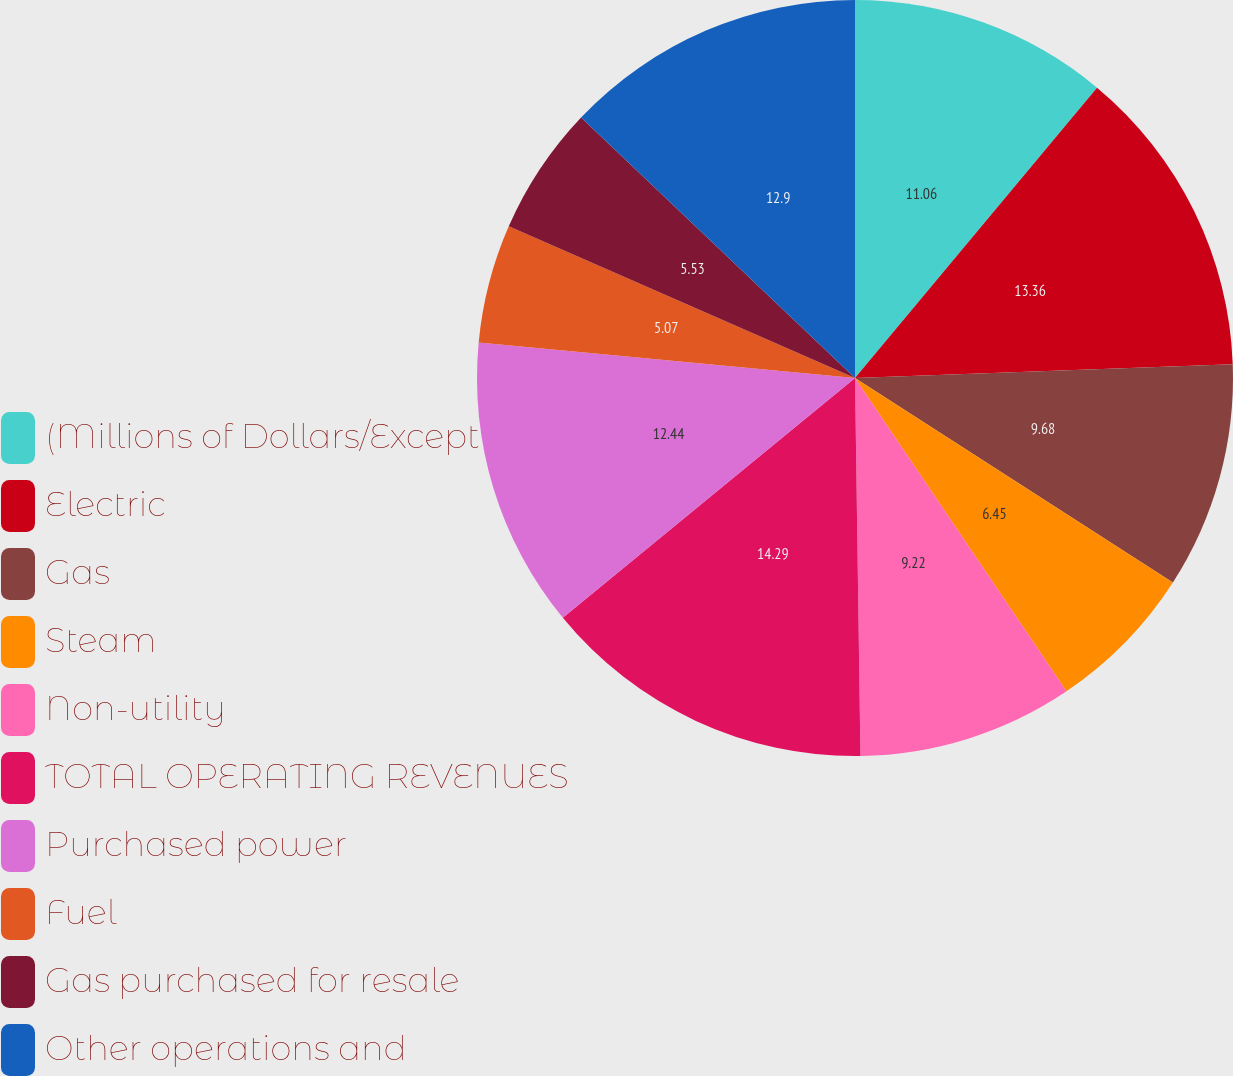Convert chart. <chart><loc_0><loc_0><loc_500><loc_500><pie_chart><fcel>(Millions of Dollars/Except<fcel>Electric<fcel>Gas<fcel>Steam<fcel>Non-utility<fcel>TOTAL OPERATING REVENUES<fcel>Purchased power<fcel>Fuel<fcel>Gas purchased for resale<fcel>Other operations and<nl><fcel>11.06%<fcel>13.36%<fcel>9.68%<fcel>6.45%<fcel>9.22%<fcel>14.29%<fcel>12.44%<fcel>5.07%<fcel>5.53%<fcel>12.9%<nl></chart> 